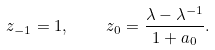Convert formula to latex. <formula><loc_0><loc_0><loc_500><loc_500>z _ { - 1 } = 1 , \quad z _ { 0 } = \frac { \lambda - \lambda ^ { - 1 } } { 1 + a _ { 0 } } .</formula> 